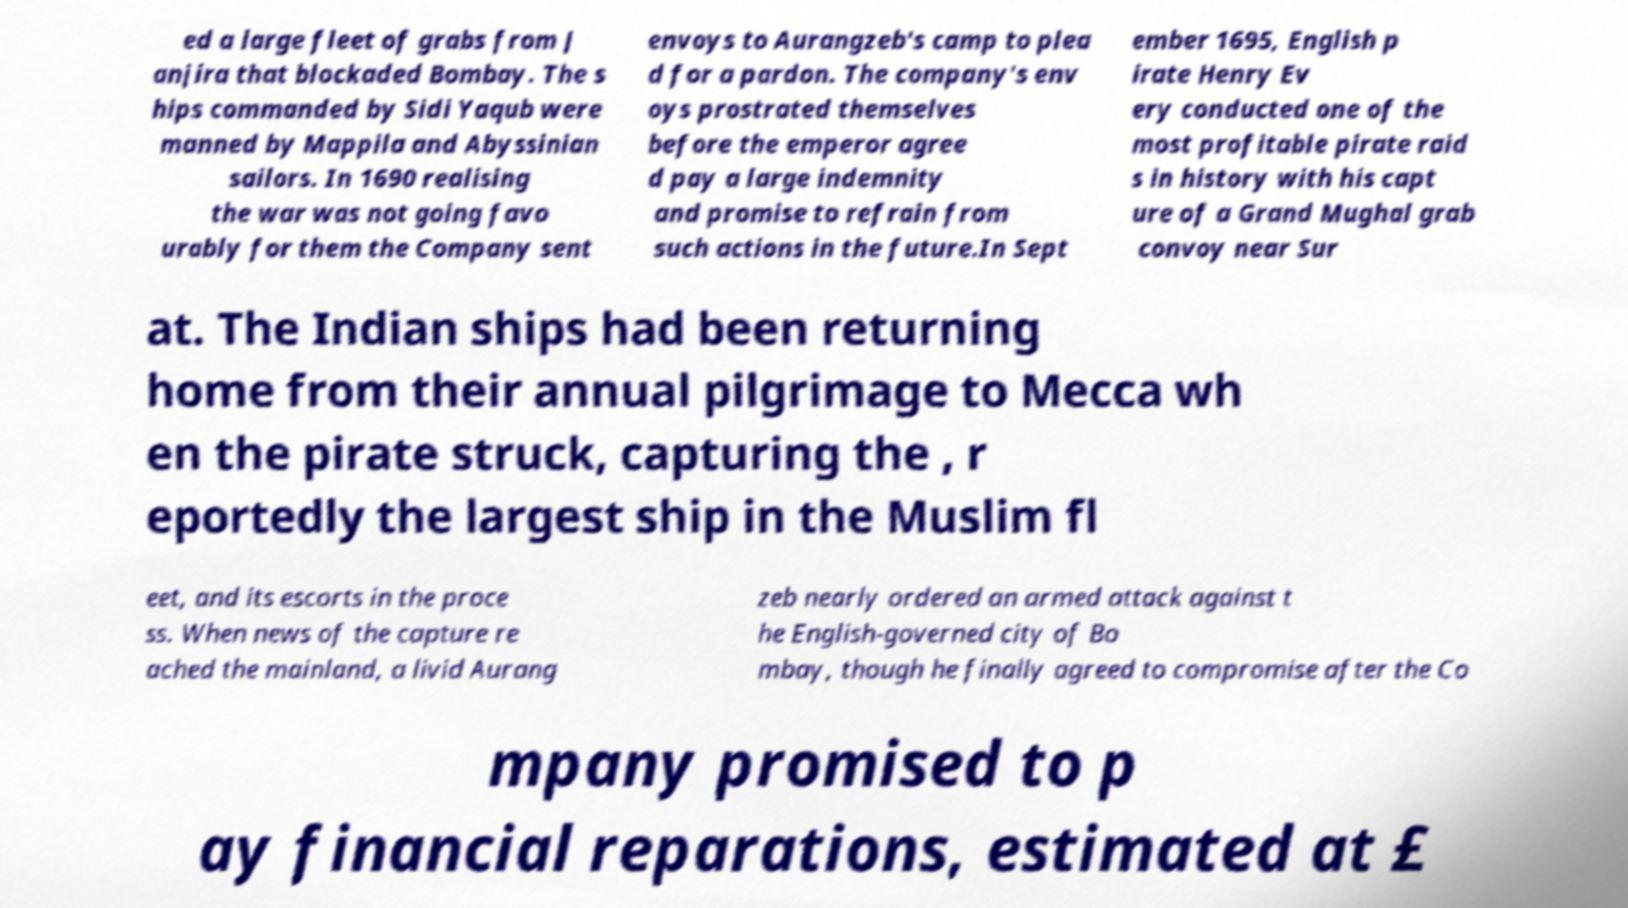Please identify and transcribe the text found in this image. ed a large fleet of grabs from J anjira that blockaded Bombay. The s hips commanded by Sidi Yaqub were manned by Mappila and Abyssinian sailors. In 1690 realising the war was not going favo urably for them the Company sent envoys to Aurangzeb's camp to plea d for a pardon. The company's env oys prostrated themselves before the emperor agree d pay a large indemnity and promise to refrain from such actions in the future.In Sept ember 1695, English p irate Henry Ev ery conducted one of the most profitable pirate raid s in history with his capt ure of a Grand Mughal grab convoy near Sur at. The Indian ships had been returning home from their annual pilgrimage to Mecca wh en the pirate struck, capturing the , r eportedly the largest ship in the Muslim fl eet, and its escorts in the proce ss. When news of the capture re ached the mainland, a livid Aurang zeb nearly ordered an armed attack against t he English-governed city of Bo mbay, though he finally agreed to compromise after the Co mpany promised to p ay financial reparations, estimated at £ 